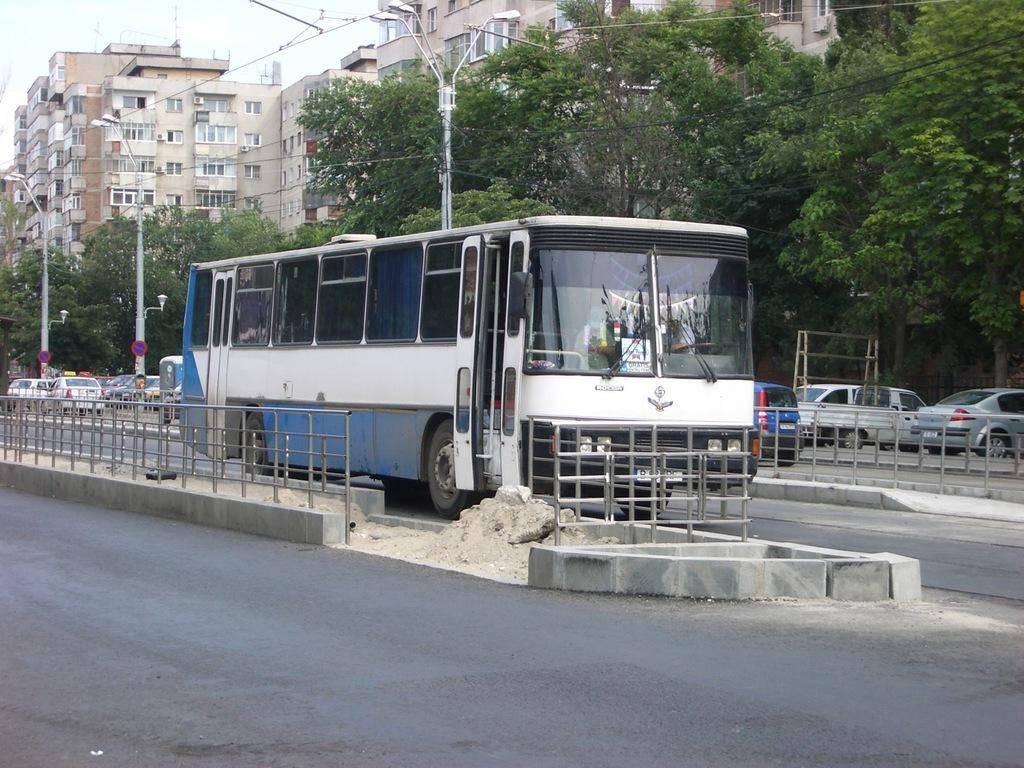Please provide a concise description of this image. In this picture we can see a bus, fences, sand, roads, cars, electric poles, sign boards, trees, buildings with windows and some objects and in the background we can see the sky. 